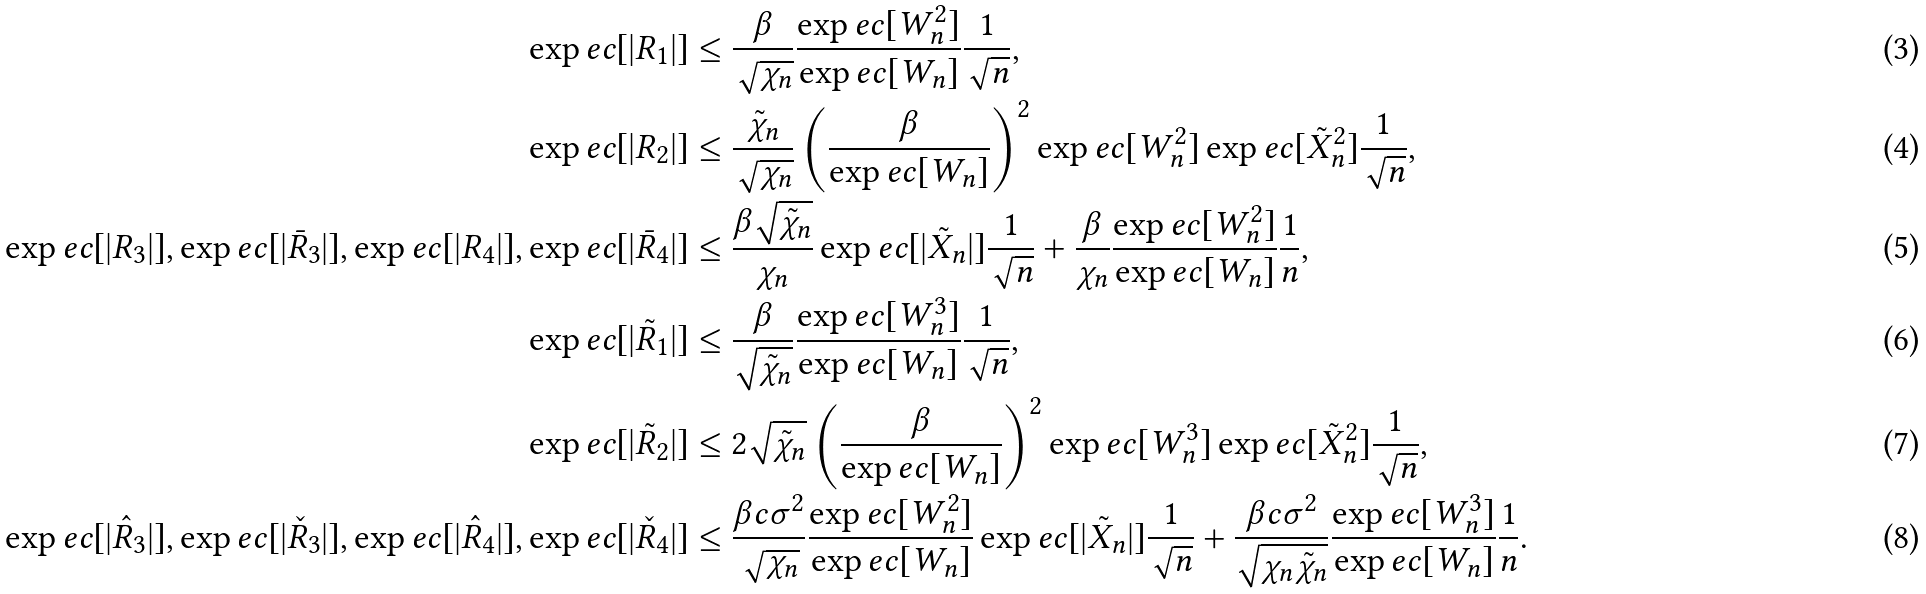<formula> <loc_0><loc_0><loc_500><loc_500>\exp e c [ | R _ { 1 } | ] & \leq \frac { \beta } { \sqrt { \chi _ { n } } } \frac { \exp e c [ W _ { n } ^ { 2 } ] } { \exp e c [ W _ { n } ] } \frac { 1 } { \sqrt { n } } , \\ \exp e c [ | R _ { 2 } | ] & \leq \frac { \tilde { \chi } _ { n } } { \sqrt { \chi _ { n } } } \left ( \frac { \beta } { \exp e c [ W _ { n } ] } \right ) ^ { 2 } \exp e c [ W _ { n } ^ { 2 } ] \exp e c [ \tilde { X } _ { n } ^ { 2 } ] \frac { 1 } { \sqrt { n } } , \\ \exp e c [ | R _ { 3 } | ] , \exp e c [ | \bar { R } _ { 3 } | ] , \exp e c [ | R _ { 4 } | ] , \exp e c [ | \bar { R } _ { 4 } | ] & \leq \frac { \beta \sqrt { \tilde { \chi } _ { n } } } { \chi _ { n } } \exp e c [ | \tilde { X } _ { n } | ] \frac { 1 } { \sqrt { n } } + \frac { \beta } { \chi _ { n } } \frac { \exp e c [ W _ { n } ^ { 2 } ] } { \exp e c [ W _ { n } ] } \frac { 1 } { n } , \\ \exp e c [ | \tilde { R } _ { 1 } | ] & \leq \frac { \beta } { \sqrt { \tilde { \chi } _ { n } } } \frac { \exp e c [ W _ { n } ^ { 3 } ] } { \exp e c [ W _ { n } ] } \frac { 1 } { \sqrt { n } } , \\ \exp e c [ | \tilde { R } _ { 2 } | ] & \leq 2 \sqrt { \tilde { \chi } _ { n } } \left ( \frac { \beta } { \exp e c [ W _ { n } ] } \right ) ^ { 2 } \exp e c [ W _ { n } ^ { 3 } ] \exp e c [ \tilde { X } _ { n } ^ { 2 } ] \frac { 1 } { \sqrt { n } } , \\ \exp e c [ | \hat { R } _ { 3 } | ] , \exp e c [ | \check { R } _ { 3 } | ] , \exp e c [ | \hat { R } _ { 4 } | ] , \exp e c [ | \check { R } _ { 4 } | ] & \leq \frac { \beta c \sigma ^ { 2 } } { \sqrt { \chi _ { n } } } \frac { \exp e c [ W _ { n } ^ { 2 } ] } { \exp e c [ W _ { n } ] } \exp e c [ | \tilde { X } _ { n } | ] \frac { 1 } { \sqrt { n } } + \frac { \beta c \sigma ^ { 2 } } { \sqrt { \chi _ { n } \tilde { \chi } _ { n } } } \frac { \exp e c [ W _ { n } ^ { 3 } ] } { \exp e c [ W _ { n } ] } \frac { 1 } { n } .</formula> 